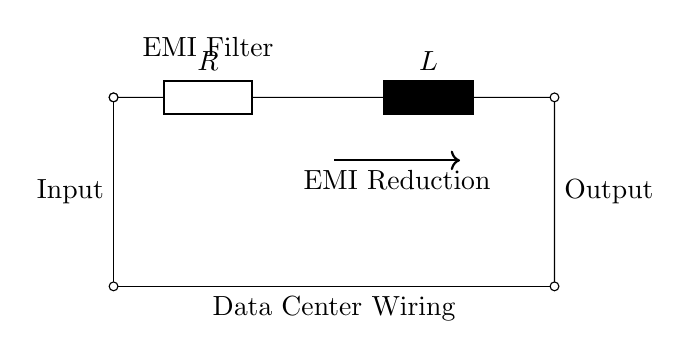What is the component at the top of the circuit? The top component in the circuit diagram is an inductor, labeled L.
Answer: Inductor What type of filter is represented in this circuit? The circuit represents an EMI filter, indicated by the labeling above it.
Answer: EMI filter What is connected in series with the inductor? In series with the inductor, there is a resistor, labeled R.
Answer: Resistor What does the arrow in the circuit indicate? The arrow indicates the direction of signal flow and suggests the purpose of the circuit, which is EMI reduction.
Answer: EMI reduction What effect does the RL filter have on the data center wiring? The RL filter reduces electromagnetic interference in the wiring, improving signal quality.
Answer: EMI reduction What is the input to this circuit? The input to this circuit comes from the data center wiring, indicated at the left side as "Input."
Answer: Data center wiring What happens to the signal at the output? The signal at the output is filtered and ideally has reduced electromagnetic interference.
Answer: Filtered signal 